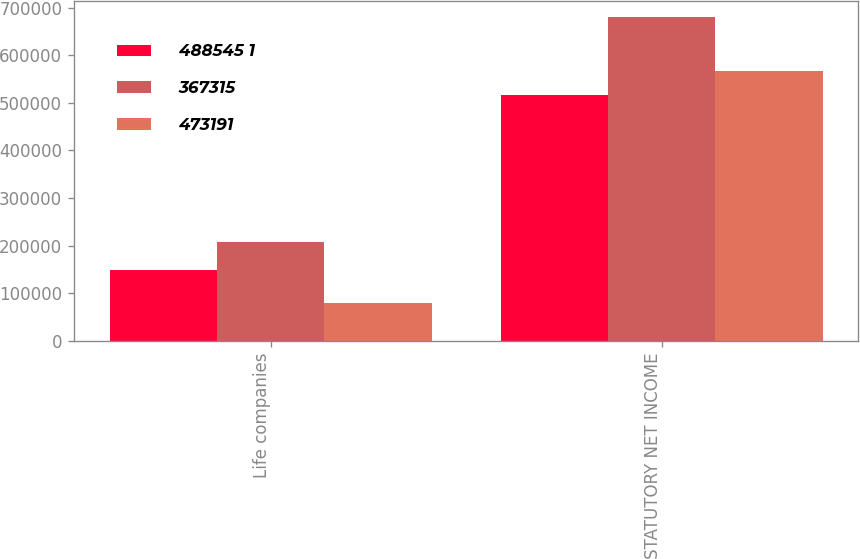<chart> <loc_0><loc_0><loc_500><loc_500><stacked_bar_chart><ecel><fcel>Life companies<fcel>TOTAL STATUTORY NET INCOME<nl><fcel>488545 1<fcel>148554<fcel>515869<nl><fcel>367315<fcel>206817<fcel>680008<nl><fcel>473191<fcel>78880<fcel>567425<nl></chart> 